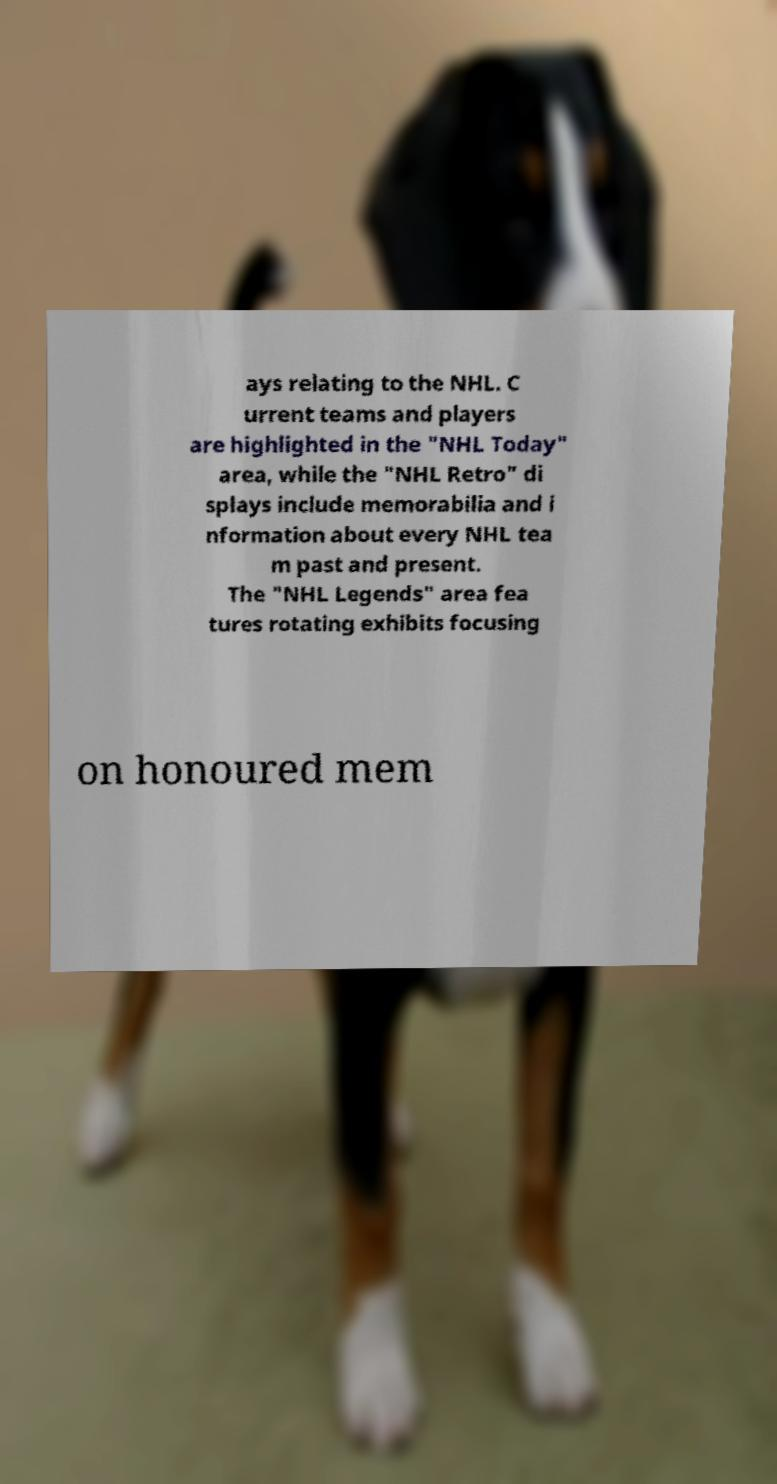Could you extract and type out the text from this image? ays relating to the NHL. C urrent teams and players are highlighted in the "NHL Today" area, while the "NHL Retro" di splays include memorabilia and i nformation about every NHL tea m past and present. The "NHL Legends" area fea tures rotating exhibits focusing on honoured mem 